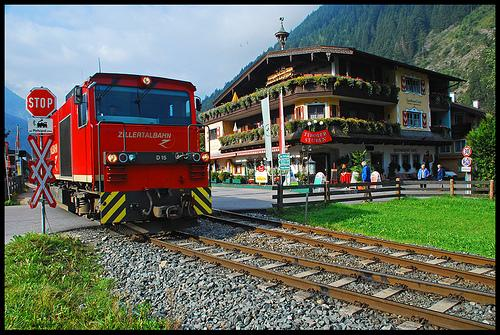What zone is this area? loading 